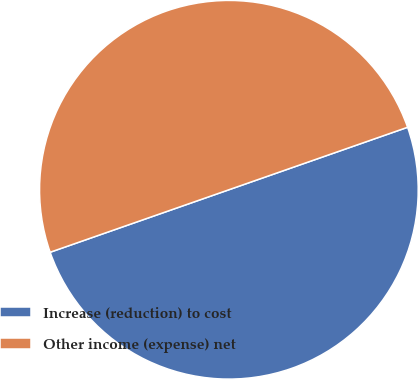<chart> <loc_0><loc_0><loc_500><loc_500><pie_chart><fcel>Increase (reduction) to cost<fcel>Other income (expense) net<nl><fcel>50.0%<fcel>50.0%<nl></chart> 